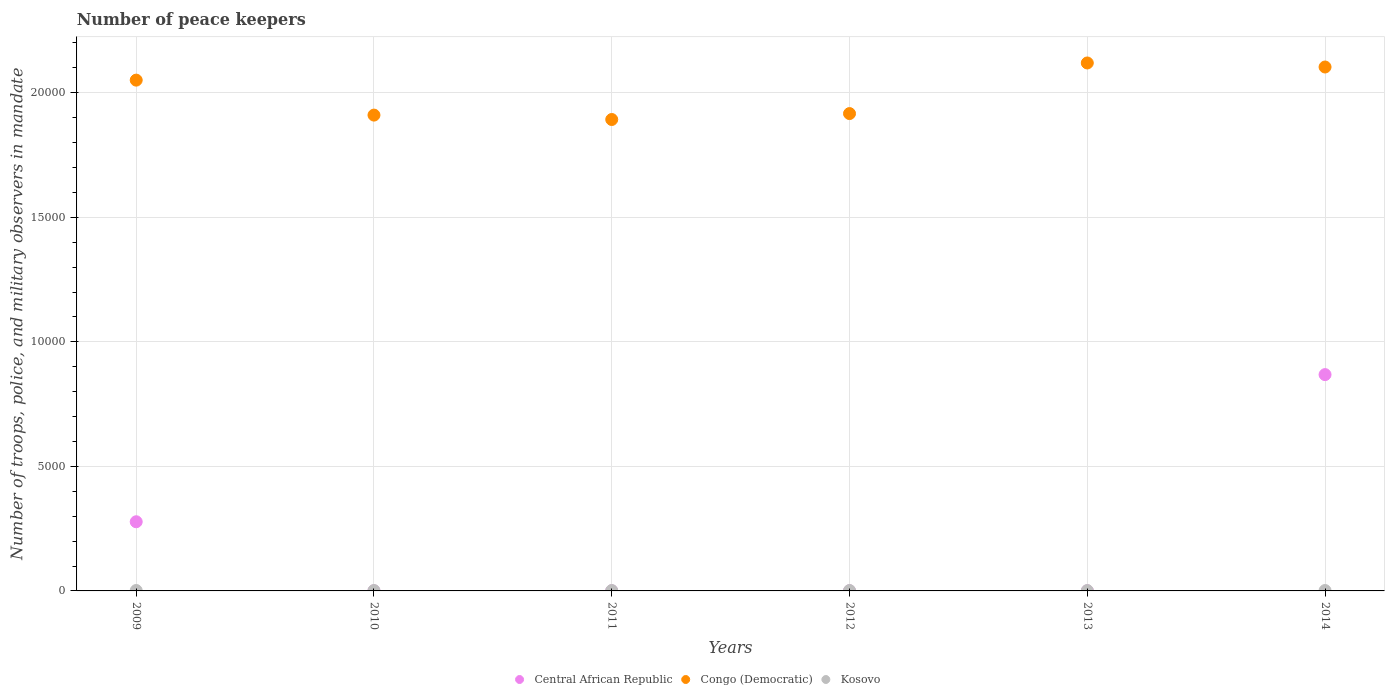How many different coloured dotlines are there?
Provide a succinct answer. 3. What is the number of peace keepers in in Central African Republic in 2009?
Make the answer very short. 2777. Across all years, what is the maximum number of peace keepers in in Kosovo?
Make the answer very short. 17. Across all years, what is the minimum number of peace keepers in in Congo (Democratic)?
Give a very brief answer. 1.89e+04. What is the total number of peace keepers in in Congo (Democratic) in the graph?
Offer a terse response. 1.20e+05. What is the difference between the number of peace keepers in in Congo (Democratic) in 2009 and that in 2014?
Your answer should be compact. -527. What is the difference between the number of peace keepers in in Congo (Democratic) in 2011 and the number of peace keepers in in Kosovo in 2014?
Offer a very short reply. 1.89e+04. What is the average number of peace keepers in in Congo (Democratic) per year?
Provide a short and direct response. 2.00e+04. In how many years, is the number of peace keepers in in Kosovo greater than 14000?
Make the answer very short. 0. What is the ratio of the number of peace keepers in in Kosovo in 2010 to that in 2011?
Provide a short and direct response. 1. Is the difference between the number of peace keepers in in Kosovo in 2010 and 2011 greater than the difference between the number of peace keepers in in Central African Republic in 2010 and 2011?
Offer a terse response. Yes. What is the difference between the highest and the second highest number of peace keepers in in Central African Republic?
Your response must be concise. 5908. In how many years, is the number of peace keepers in in Congo (Democratic) greater than the average number of peace keepers in in Congo (Democratic) taken over all years?
Make the answer very short. 3. Is the sum of the number of peace keepers in in Congo (Democratic) in 2011 and 2014 greater than the maximum number of peace keepers in in Central African Republic across all years?
Your answer should be compact. Yes. Is the number of peace keepers in in Congo (Democratic) strictly greater than the number of peace keepers in in Central African Republic over the years?
Your answer should be compact. Yes. How many dotlines are there?
Keep it short and to the point. 3. Are the values on the major ticks of Y-axis written in scientific E-notation?
Your answer should be very brief. No. Where does the legend appear in the graph?
Your response must be concise. Bottom center. How many legend labels are there?
Offer a very short reply. 3. What is the title of the graph?
Give a very brief answer. Number of peace keepers. What is the label or title of the X-axis?
Provide a succinct answer. Years. What is the label or title of the Y-axis?
Your answer should be compact. Number of troops, police, and military observers in mandate. What is the Number of troops, police, and military observers in mandate in Central African Republic in 2009?
Offer a very short reply. 2777. What is the Number of troops, police, and military observers in mandate in Congo (Democratic) in 2009?
Provide a short and direct response. 2.05e+04. What is the Number of troops, police, and military observers in mandate in Kosovo in 2009?
Your answer should be very brief. 17. What is the Number of troops, police, and military observers in mandate of Congo (Democratic) in 2010?
Offer a terse response. 1.91e+04. What is the Number of troops, police, and military observers in mandate of Kosovo in 2010?
Ensure brevity in your answer.  16. What is the Number of troops, police, and military observers in mandate in Central African Republic in 2011?
Your response must be concise. 4. What is the Number of troops, police, and military observers in mandate of Congo (Democratic) in 2011?
Your answer should be very brief. 1.89e+04. What is the Number of troops, police, and military observers in mandate of Central African Republic in 2012?
Your response must be concise. 4. What is the Number of troops, police, and military observers in mandate of Congo (Democratic) in 2012?
Provide a succinct answer. 1.92e+04. What is the Number of troops, police, and military observers in mandate in Kosovo in 2012?
Offer a very short reply. 16. What is the Number of troops, police, and military observers in mandate of Central African Republic in 2013?
Your response must be concise. 4. What is the Number of troops, police, and military observers in mandate in Congo (Democratic) in 2013?
Your answer should be very brief. 2.12e+04. What is the Number of troops, police, and military observers in mandate in Kosovo in 2013?
Make the answer very short. 14. What is the Number of troops, police, and military observers in mandate in Central African Republic in 2014?
Offer a very short reply. 8685. What is the Number of troops, police, and military observers in mandate of Congo (Democratic) in 2014?
Keep it short and to the point. 2.10e+04. Across all years, what is the maximum Number of troops, police, and military observers in mandate of Central African Republic?
Provide a succinct answer. 8685. Across all years, what is the maximum Number of troops, police, and military observers in mandate in Congo (Democratic)?
Keep it short and to the point. 2.12e+04. Across all years, what is the maximum Number of troops, police, and military observers in mandate in Kosovo?
Give a very brief answer. 17. Across all years, what is the minimum Number of troops, police, and military observers in mandate of Central African Republic?
Your answer should be very brief. 3. Across all years, what is the minimum Number of troops, police, and military observers in mandate of Congo (Democratic)?
Your answer should be compact. 1.89e+04. Across all years, what is the minimum Number of troops, police, and military observers in mandate in Kosovo?
Provide a short and direct response. 14. What is the total Number of troops, police, and military observers in mandate in Central African Republic in the graph?
Offer a very short reply. 1.15e+04. What is the total Number of troops, police, and military observers in mandate in Congo (Democratic) in the graph?
Your answer should be very brief. 1.20e+05. What is the difference between the Number of troops, police, and military observers in mandate of Central African Republic in 2009 and that in 2010?
Keep it short and to the point. 2774. What is the difference between the Number of troops, police, and military observers in mandate of Congo (Democratic) in 2009 and that in 2010?
Your answer should be very brief. 1404. What is the difference between the Number of troops, police, and military observers in mandate in Kosovo in 2009 and that in 2010?
Give a very brief answer. 1. What is the difference between the Number of troops, police, and military observers in mandate of Central African Republic in 2009 and that in 2011?
Offer a terse response. 2773. What is the difference between the Number of troops, police, and military observers in mandate of Congo (Democratic) in 2009 and that in 2011?
Your answer should be compact. 1581. What is the difference between the Number of troops, police, and military observers in mandate in Kosovo in 2009 and that in 2011?
Provide a short and direct response. 1. What is the difference between the Number of troops, police, and military observers in mandate of Central African Republic in 2009 and that in 2012?
Ensure brevity in your answer.  2773. What is the difference between the Number of troops, police, and military observers in mandate in Congo (Democratic) in 2009 and that in 2012?
Ensure brevity in your answer.  1343. What is the difference between the Number of troops, police, and military observers in mandate in Central African Republic in 2009 and that in 2013?
Offer a terse response. 2773. What is the difference between the Number of troops, police, and military observers in mandate of Congo (Democratic) in 2009 and that in 2013?
Keep it short and to the point. -689. What is the difference between the Number of troops, police, and military observers in mandate of Central African Republic in 2009 and that in 2014?
Offer a very short reply. -5908. What is the difference between the Number of troops, police, and military observers in mandate of Congo (Democratic) in 2009 and that in 2014?
Provide a short and direct response. -527. What is the difference between the Number of troops, police, and military observers in mandate in Central African Republic in 2010 and that in 2011?
Ensure brevity in your answer.  -1. What is the difference between the Number of troops, police, and military observers in mandate of Congo (Democratic) in 2010 and that in 2011?
Your response must be concise. 177. What is the difference between the Number of troops, police, and military observers in mandate of Kosovo in 2010 and that in 2011?
Give a very brief answer. 0. What is the difference between the Number of troops, police, and military observers in mandate of Central African Republic in 2010 and that in 2012?
Provide a succinct answer. -1. What is the difference between the Number of troops, police, and military observers in mandate in Congo (Democratic) in 2010 and that in 2012?
Your response must be concise. -61. What is the difference between the Number of troops, police, and military observers in mandate in Kosovo in 2010 and that in 2012?
Offer a very short reply. 0. What is the difference between the Number of troops, police, and military observers in mandate of Congo (Democratic) in 2010 and that in 2013?
Ensure brevity in your answer.  -2093. What is the difference between the Number of troops, police, and military observers in mandate of Kosovo in 2010 and that in 2013?
Your answer should be very brief. 2. What is the difference between the Number of troops, police, and military observers in mandate in Central African Republic in 2010 and that in 2014?
Ensure brevity in your answer.  -8682. What is the difference between the Number of troops, police, and military observers in mandate of Congo (Democratic) in 2010 and that in 2014?
Your answer should be very brief. -1931. What is the difference between the Number of troops, police, and military observers in mandate of Kosovo in 2010 and that in 2014?
Provide a succinct answer. 0. What is the difference between the Number of troops, police, and military observers in mandate in Central African Republic in 2011 and that in 2012?
Give a very brief answer. 0. What is the difference between the Number of troops, police, and military observers in mandate in Congo (Democratic) in 2011 and that in 2012?
Offer a very short reply. -238. What is the difference between the Number of troops, police, and military observers in mandate of Kosovo in 2011 and that in 2012?
Offer a very short reply. 0. What is the difference between the Number of troops, police, and military observers in mandate in Congo (Democratic) in 2011 and that in 2013?
Provide a short and direct response. -2270. What is the difference between the Number of troops, police, and military observers in mandate of Central African Republic in 2011 and that in 2014?
Your answer should be compact. -8681. What is the difference between the Number of troops, police, and military observers in mandate of Congo (Democratic) in 2011 and that in 2014?
Provide a succinct answer. -2108. What is the difference between the Number of troops, police, and military observers in mandate in Kosovo in 2011 and that in 2014?
Provide a succinct answer. 0. What is the difference between the Number of troops, police, and military observers in mandate of Congo (Democratic) in 2012 and that in 2013?
Provide a short and direct response. -2032. What is the difference between the Number of troops, police, and military observers in mandate of Kosovo in 2012 and that in 2013?
Your answer should be compact. 2. What is the difference between the Number of troops, police, and military observers in mandate in Central African Republic in 2012 and that in 2014?
Ensure brevity in your answer.  -8681. What is the difference between the Number of troops, police, and military observers in mandate of Congo (Democratic) in 2012 and that in 2014?
Your response must be concise. -1870. What is the difference between the Number of troops, police, and military observers in mandate in Central African Republic in 2013 and that in 2014?
Give a very brief answer. -8681. What is the difference between the Number of troops, police, and military observers in mandate of Congo (Democratic) in 2013 and that in 2014?
Your answer should be very brief. 162. What is the difference between the Number of troops, police, and military observers in mandate in Kosovo in 2013 and that in 2014?
Provide a short and direct response. -2. What is the difference between the Number of troops, police, and military observers in mandate of Central African Republic in 2009 and the Number of troops, police, and military observers in mandate of Congo (Democratic) in 2010?
Provide a succinct answer. -1.63e+04. What is the difference between the Number of troops, police, and military observers in mandate in Central African Republic in 2009 and the Number of troops, police, and military observers in mandate in Kosovo in 2010?
Offer a very short reply. 2761. What is the difference between the Number of troops, police, and military observers in mandate of Congo (Democratic) in 2009 and the Number of troops, police, and military observers in mandate of Kosovo in 2010?
Keep it short and to the point. 2.05e+04. What is the difference between the Number of troops, police, and military observers in mandate of Central African Republic in 2009 and the Number of troops, police, and military observers in mandate of Congo (Democratic) in 2011?
Make the answer very short. -1.62e+04. What is the difference between the Number of troops, police, and military observers in mandate in Central African Republic in 2009 and the Number of troops, police, and military observers in mandate in Kosovo in 2011?
Offer a very short reply. 2761. What is the difference between the Number of troops, police, and military observers in mandate of Congo (Democratic) in 2009 and the Number of troops, police, and military observers in mandate of Kosovo in 2011?
Keep it short and to the point. 2.05e+04. What is the difference between the Number of troops, police, and military observers in mandate in Central African Republic in 2009 and the Number of troops, police, and military observers in mandate in Congo (Democratic) in 2012?
Your answer should be very brief. -1.64e+04. What is the difference between the Number of troops, police, and military observers in mandate in Central African Republic in 2009 and the Number of troops, police, and military observers in mandate in Kosovo in 2012?
Your response must be concise. 2761. What is the difference between the Number of troops, police, and military observers in mandate of Congo (Democratic) in 2009 and the Number of troops, police, and military observers in mandate of Kosovo in 2012?
Keep it short and to the point. 2.05e+04. What is the difference between the Number of troops, police, and military observers in mandate in Central African Republic in 2009 and the Number of troops, police, and military observers in mandate in Congo (Democratic) in 2013?
Keep it short and to the point. -1.84e+04. What is the difference between the Number of troops, police, and military observers in mandate of Central African Republic in 2009 and the Number of troops, police, and military observers in mandate of Kosovo in 2013?
Ensure brevity in your answer.  2763. What is the difference between the Number of troops, police, and military observers in mandate in Congo (Democratic) in 2009 and the Number of troops, police, and military observers in mandate in Kosovo in 2013?
Your answer should be compact. 2.05e+04. What is the difference between the Number of troops, police, and military observers in mandate of Central African Republic in 2009 and the Number of troops, police, and military observers in mandate of Congo (Democratic) in 2014?
Your answer should be very brief. -1.83e+04. What is the difference between the Number of troops, police, and military observers in mandate of Central African Republic in 2009 and the Number of troops, police, and military observers in mandate of Kosovo in 2014?
Offer a very short reply. 2761. What is the difference between the Number of troops, police, and military observers in mandate of Congo (Democratic) in 2009 and the Number of troops, police, and military observers in mandate of Kosovo in 2014?
Offer a very short reply. 2.05e+04. What is the difference between the Number of troops, police, and military observers in mandate of Central African Republic in 2010 and the Number of troops, police, and military observers in mandate of Congo (Democratic) in 2011?
Ensure brevity in your answer.  -1.89e+04. What is the difference between the Number of troops, police, and military observers in mandate in Central African Republic in 2010 and the Number of troops, police, and military observers in mandate in Kosovo in 2011?
Provide a short and direct response. -13. What is the difference between the Number of troops, police, and military observers in mandate of Congo (Democratic) in 2010 and the Number of troops, police, and military observers in mandate of Kosovo in 2011?
Your answer should be very brief. 1.91e+04. What is the difference between the Number of troops, police, and military observers in mandate of Central African Republic in 2010 and the Number of troops, police, and military observers in mandate of Congo (Democratic) in 2012?
Your response must be concise. -1.92e+04. What is the difference between the Number of troops, police, and military observers in mandate of Congo (Democratic) in 2010 and the Number of troops, police, and military observers in mandate of Kosovo in 2012?
Ensure brevity in your answer.  1.91e+04. What is the difference between the Number of troops, police, and military observers in mandate of Central African Republic in 2010 and the Number of troops, police, and military observers in mandate of Congo (Democratic) in 2013?
Keep it short and to the point. -2.12e+04. What is the difference between the Number of troops, police, and military observers in mandate of Central African Republic in 2010 and the Number of troops, police, and military observers in mandate of Kosovo in 2013?
Offer a terse response. -11. What is the difference between the Number of troops, police, and military observers in mandate of Congo (Democratic) in 2010 and the Number of troops, police, and military observers in mandate of Kosovo in 2013?
Give a very brief answer. 1.91e+04. What is the difference between the Number of troops, police, and military observers in mandate of Central African Republic in 2010 and the Number of troops, police, and military observers in mandate of Congo (Democratic) in 2014?
Offer a terse response. -2.10e+04. What is the difference between the Number of troops, police, and military observers in mandate of Central African Republic in 2010 and the Number of troops, police, and military observers in mandate of Kosovo in 2014?
Give a very brief answer. -13. What is the difference between the Number of troops, police, and military observers in mandate of Congo (Democratic) in 2010 and the Number of troops, police, and military observers in mandate of Kosovo in 2014?
Keep it short and to the point. 1.91e+04. What is the difference between the Number of troops, police, and military observers in mandate of Central African Republic in 2011 and the Number of troops, police, and military observers in mandate of Congo (Democratic) in 2012?
Offer a very short reply. -1.92e+04. What is the difference between the Number of troops, police, and military observers in mandate in Central African Republic in 2011 and the Number of troops, police, and military observers in mandate in Kosovo in 2012?
Keep it short and to the point. -12. What is the difference between the Number of troops, police, and military observers in mandate of Congo (Democratic) in 2011 and the Number of troops, police, and military observers in mandate of Kosovo in 2012?
Make the answer very short. 1.89e+04. What is the difference between the Number of troops, police, and military observers in mandate in Central African Republic in 2011 and the Number of troops, police, and military observers in mandate in Congo (Democratic) in 2013?
Your answer should be very brief. -2.12e+04. What is the difference between the Number of troops, police, and military observers in mandate of Central African Republic in 2011 and the Number of troops, police, and military observers in mandate of Kosovo in 2013?
Provide a succinct answer. -10. What is the difference between the Number of troops, police, and military observers in mandate in Congo (Democratic) in 2011 and the Number of troops, police, and military observers in mandate in Kosovo in 2013?
Offer a very short reply. 1.89e+04. What is the difference between the Number of troops, police, and military observers in mandate of Central African Republic in 2011 and the Number of troops, police, and military observers in mandate of Congo (Democratic) in 2014?
Your answer should be very brief. -2.10e+04. What is the difference between the Number of troops, police, and military observers in mandate in Central African Republic in 2011 and the Number of troops, police, and military observers in mandate in Kosovo in 2014?
Your answer should be very brief. -12. What is the difference between the Number of troops, police, and military observers in mandate of Congo (Democratic) in 2011 and the Number of troops, police, and military observers in mandate of Kosovo in 2014?
Provide a succinct answer. 1.89e+04. What is the difference between the Number of troops, police, and military observers in mandate in Central African Republic in 2012 and the Number of troops, police, and military observers in mandate in Congo (Democratic) in 2013?
Give a very brief answer. -2.12e+04. What is the difference between the Number of troops, police, and military observers in mandate in Congo (Democratic) in 2012 and the Number of troops, police, and military observers in mandate in Kosovo in 2013?
Your answer should be compact. 1.92e+04. What is the difference between the Number of troops, police, and military observers in mandate of Central African Republic in 2012 and the Number of troops, police, and military observers in mandate of Congo (Democratic) in 2014?
Provide a succinct answer. -2.10e+04. What is the difference between the Number of troops, police, and military observers in mandate of Congo (Democratic) in 2012 and the Number of troops, police, and military observers in mandate of Kosovo in 2014?
Make the answer very short. 1.92e+04. What is the difference between the Number of troops, police, and military observers in mandate of Central African Republic in 2013 and the Number of troops, police, and military observers in mandate of Congo (Democratic) in 2014?
Provide a succinct answer. -2.10e+04. What is the difference between the Number of troops, police, and military observers in mandate of Central African Republic in 2013 and the Number of troops, police, and military observers in mandate of Kosovo in 2014?
Your answer should be very brief. -12. What is the difference between the Number of troops, police, and military observers in mandate in Congo (Democratic) in 2013 and the Number of troops, police, and military observers in mandate in Kosovo in 2014?
Offer a terse response. 2.12e+04. What is the average Number of troops, police, and military observers in mandate in Central African Republic per year?
Make the answer very short. 1912.83. What is the average Number of troops, police, and military observers in mandate in Congo (Democratic) per year?
Your answer should be compact. 2.00e+04. What is the average Number of troops, police, and military observers in mandate of Kosovo per year?
Provide a short and direct response. 15.83. In the year 2009, what is the difference between the Number of troops, police, and military observers in mandate in Central African Republic and Number of troops, police, and military observers in mandate in Congo (Democratic)?
Offer a terse response. -1.77e+04. In the year 2009, what is the difference between the Number of troops, police, and military observers in mandate in Central African Republic and Number of troops, police, and military observers in mandate in Kosovo?
Your response must be concise. 2760. In the year 2009, what is the difference between the Number of troops, police, and military observers in mandate of Congo (Democratic) and Number of troops, police, and military observers in mandate of Kosovo?
Offer a very short reply. 2.05e+04. In the year 2010, what is the difference between the Number of troops, police, and military observers in mandate of Central African Republic and Number of troops, police, and military observers in mandate of Congo (Democratic)?
Offer a terse response. -1.91e+04. In the year 2010, what is the difference between the Number of troops, police, and military observers in mandate of Congo (Democratic) and Number of troops, police, and military observers in mandate of Kosovo?
Make the answer very short. 1.91e+04. In the year 2011, what is the difference between the Number of troops, police, and military observers in mandate of Central African Republic and Number of troops, police, and military observers in mandate of Congo (Democratic)?
Your answer should be compact. -1.89e+04. In the year 2011, what is the difference between the Number of troops, police, and military observers in mandate of Central African Republic and Number of troops, police, and military observers in mandate of Kosovo?
Ensure brevity in your answer.  -12. In the year 2011, what is the difference between the Number of troops, police, and military observers in mandate in Congo (Democratic) and Number of troops, police, and military observers in mandate in Kosovo?
Offer a terse response. 1.89e+04. In the year 2012, what is the difference between the Number of troops, police, and military observers in mandate of Central African Republic and Number of troops, police, and military observers in mandate of Congo (Democratic)?
Make the answer very short. -1.92e+04. In the year 2012, what is the difference between the Number of troops, police, and military observers in mandate in Congo (Democratic) and Number of troops, police, and military observers in mandate in Kosovo?
Your answer should be very brief. 1.92e+04. In the year 2013, what is the difference between the Number of troops, police, and military observers in mandate in Central African Republic and Number of troops, police, and military observers in mandate in Congo (Democratic)?
Offer a terse response. -2.12e+04. In the year 2013, what is the difference between the Number of troops, police, and military observers in mandate of Central African Republic and Number of troops, police, and military observers in mandate of Kosovo?
Ensure brevity in your answer.  -10. In the year 2013, what is the difference between the Number of troops, police, and military observers in mandate of Congo (Democratic) and Number of troops, police, and military observers in mandate of Kosovo?
Provide a short and direct response. 2.12e+04. In the year 2014, what is the difference between the Number of troops, police, and military observers in mandate in Central African Republic and Number of troops, police, and military observers in mandate in Congo (Democratic)?
Make the answer very short. -1.24e+04. In the year 2014, what is the difference between the Number of troops, police, and military observers in mandate of Central African Republic and Number of troops, police, and military observers in mandate of Kosovo?
Keep it short and to the point. 8669. In the year 2014, what is the difference between the Number of troops, police, and military observers in mandate in Congo (Democratic) and Number of troops, police, and military observers in mandate in Kosovo?
Give a very brief answer. 2.10e+04. What is the ratio of the Number of troops, police, and military observers in mandate in Central African Republic in 2009 to that in 2010?
Give a very brief answer. 925.67. What is the ratio of the Number of troops, police, and military observers in mandate of Congo (Democratic) in 2009 to that in 2010?
Your answer should be compact. 1.07. What is the ratio of the Number of troops, police, and military observers in mandate of Kosovo in 2009 to that in 2010?
Provide a succinct answer. 1.06. What is the ratio of the Number of troops, police, and military observers in mandate of Central African Republic in 2009 to that in 2011?
Provide a short and direct response. 694.25. What is the ratio of the Number of troops, police, and military observers in mandate of Congo (Democratic) in 2009 to that in 2011?
Keep it short and to the point. 1.08. What is the ratio of the Number of troops, police, and military observers in mandate of Kosovo in 2009 to that in 2011?
Your response must be concise. 1.06. What is the ratio of the Number of troops, police, and military observers in mandate in Central African Republic in 2009 to that in 2012?
Ensure brevity in your answer.  694.25. What is the ratio of the Number of troops, police, and military observers in mandate in Congo (Democratic) in 2009 to that in 2012?
Ensure brevity in your answer.  1.07. What is the ratio of the Number of troops, police, and military observers in mandate of Kosovo in 2009 to that in 2012?
Offer a very short reply. 1.06. What is the ratio of the Number of troops, police, and military observers in mandate in Central African Republic in 2009 to that in 2013?
Make the answer very short. 694.25. What is the ratio of the Number of troops, police, and military observers in mandate in Congo (Democratic) in 2009 to that in 2013?
Your response must be concise. 0.97. What is the ratio of the Number of troops, police, and military observers in mandate of Kosovo in 2009 to that in 2013?
Offer a terse response. 1.21. What is the ratio of the Number of troops, police, and military observers in mandate in Central African Republic in 2009 to that in 2014?
Ensure brevity in your answer.  0.32. What is the ratio of the Number of troops, police, and military observers in mandate of Congo (Democratic) in 2009 to that in 2014?
Your answer should be very brief. 0.97. What is the ratio of the Number of troops, police, and military observers in mandate in Congo (Democratic) in 2010 to that in 2011?
Give a very brief answer. 1.01. What is the ratio of the Number of troops, police, and military observers in mandate of Kosovo in 2010 to that in 2011?
Keep it short and to the point. 1. What is the ratio of the Number of troops, police, and military observers in mandate in Central African Republic in 2010 to that in 2012?
Ensure brevity in your answer.  0.75. What is the ratio of the Number of troops, police, and military observers in mandate in Kosovo in 2010 to that in 2012?
Make the answer very short. 1. What is the ratio of the Number of troops, police, and military observers in mandate of Congo (Democratic) in 2010 to that in 2013?
Your answer should be very brief. 0.9. What is the ratio of the Number of troops, police, and military observers in mandate of Central African Republic in 2010 to that in 2014?
Offer a very short reply. 0. What is the ratio of the Number of troops, police, and military observers in mandate of Congo (Democratic) in 2010 to that in 2014?
Your response must be concise. 0.91. What is the ratio of the Number of troops, police, and military observers in mandate in Kosovo in 2010 to that in 2014?
Make the answer very short. 1. What is the ratio of the Number of troops, police, and military observers in mandate of Congo (Democratic) in 2011 to that in 2012?
Offer a terse response. 0.99. What is the ratio of the Number of troops, police, and military observers in mandate of Kosovo in 2011 to that in 2012?
Keep it short and to the point. 1. What is the ratio of the Number of troops, police, and military observers in mandate of Central African Republic in 2011 to that in 2013?
Offer a very short reply. 1. What is the ratio of the Number of troops, police, and military observers in mandate in Congo (Democratic) in 2011 to that in 2013?
Provide a succinct answer. 0.89. What is the ratio of the Number of troops, police, and military observers in mandate of Kosovo in 2011 to that in 2013?
Make the answer very short. 1.14. What is the ratio of the Number of troops, police, and military observers in mandate of Central African Republic in 2011 to that in 2014?
Offer a very short reply. 0. What is the ratio of the Number of troops, police, and military observers in mandate of Congo (Democratic) in 2011 to that in 2014?
Provide a succinct answer. 0.9. What is the ratio of the Number of troops, police, and military observers in mandate in Congo (Democratic) in 2012 to that in 2013?
Provide a short and direct response. 0.9. What is the ratio of the Number of troops, police, and military observers in mandate of Kosovo in 2012 to that in 2013?
Your response must be concise. 1.14. What is the ratio of the Number of troops, police, and military observers in mandate in Central African Republic in 2012 to that in 2014?
Make the answer very short. 0. What is the ratio of the Number of troops, police, and military observers in mandate in Congo (Democratic) in 2012 to that in 2014?
Give a very brief answer. 0.91. What is the ratio of the Number of troops, police, and military observers in mandate in Central African Republic in 2013 to that in 2014?
Offer a very short reply. 0. What is the ratio of the Number of troops, police, and military observers in mandate of Congo (Democratic) in 2013 to that in 2014?
Your answer should be very brief. 1.01. What is the ratio of the Number of troops, police, and military observers in mandate of Kosovo in 2013 to that in 2014?
Provide a succinct answer. 0.88. What is the difference between the highest and the second highest Number of troops, police, and military observers in mandate of Central African Republic?
Your answer should be very brief. 5908. What is the difference between the highest and the second highest Number of troops, police, and military observers in mandate of Congo (Democratic)?
Offer a terse response. 162. What is the difference between the highest and the second highest Number of troops, police, and military observers in mandate of Kosovo?
Offer a very short reply. 1. What is the difference between the highest and the lowest Number of troops, police, and military observers in mandate in Central African Republic?
Give a very brief answer. 8682. What is the difference between the highest and the lowest Number of troops, police, and military observers in mandate in Congo (Democratic)?
Ensure brevity in your answer.  2270. What is the difference between the highest and the lowest Number of troops, police, and military observers in mandate of Kosovo?
Make the answer very short. 3. 